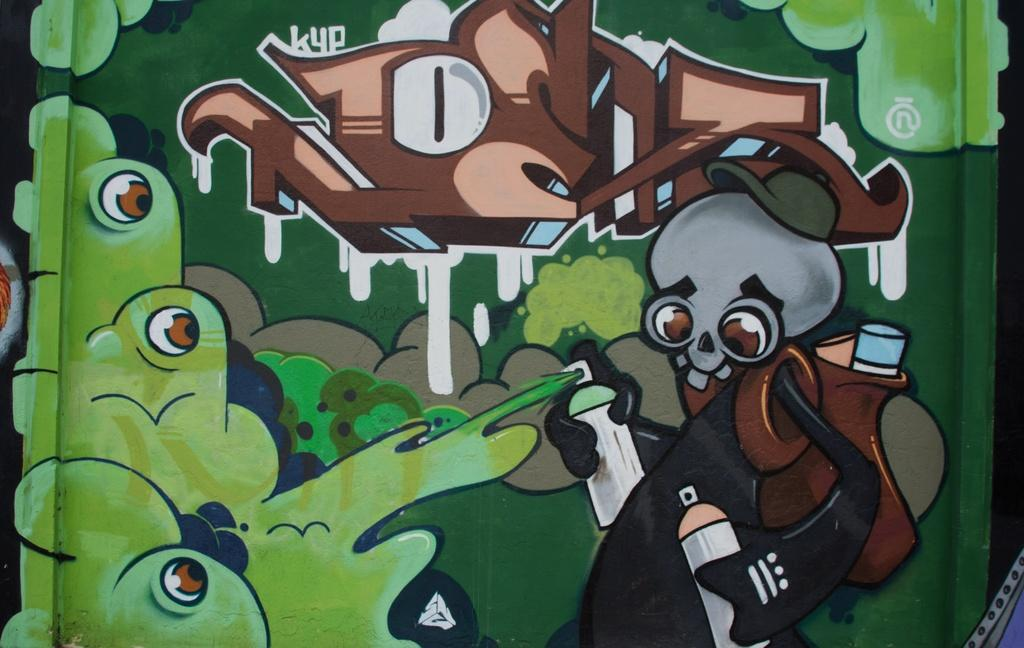What is depicted on the wall in the image? There is a cartoon painting on a wall in the image. What type of punishment is being given to the character in the cartoon painting? There is no indication of any punishment in the cartoon painting, as it is not mentioned in the provided facts. 